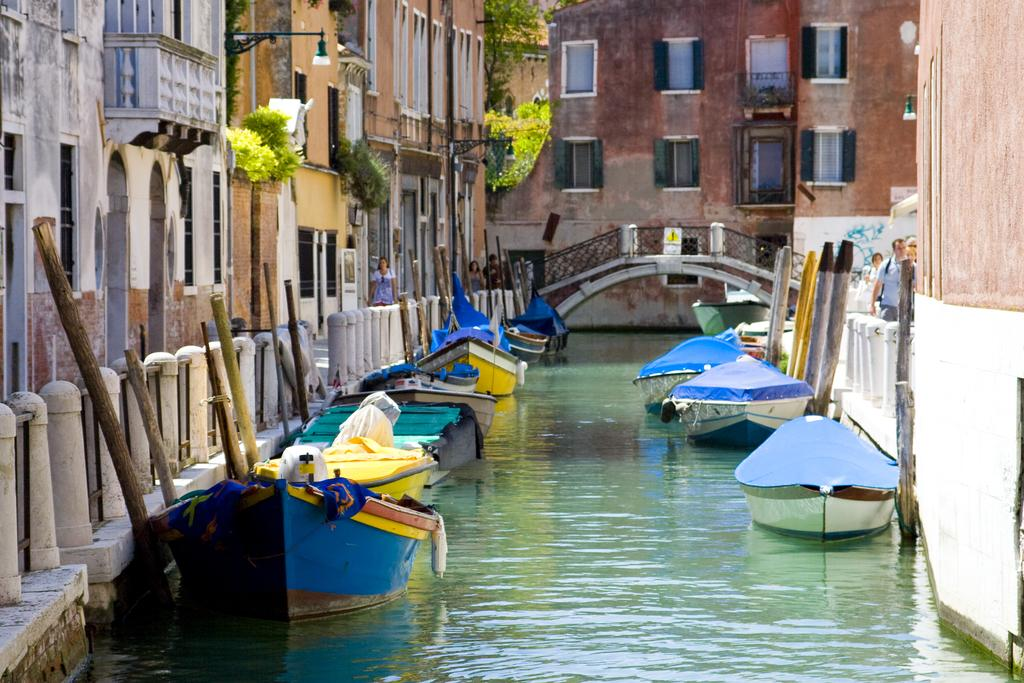What is on the water in the image? There are boats on the water in the image. What structures can be seen in the image? There are buildings visible in the image. What can be seen illuminated in the image? There are lights in the image. What type of vegetation is present in the image? There are plants in the image. What architectural feature connects two areas in the image? There is a bridge in the image. What are the persons in the image doing? There are persons walking on the surface in the image. Can you tell me how many snails are crawling on the bridge in the image? There are no snails present on the bridge in the image. What type of mice can be seen interacting with the boats in the image? There are no mice present in the image, and therefore no such interaction can be observed. 